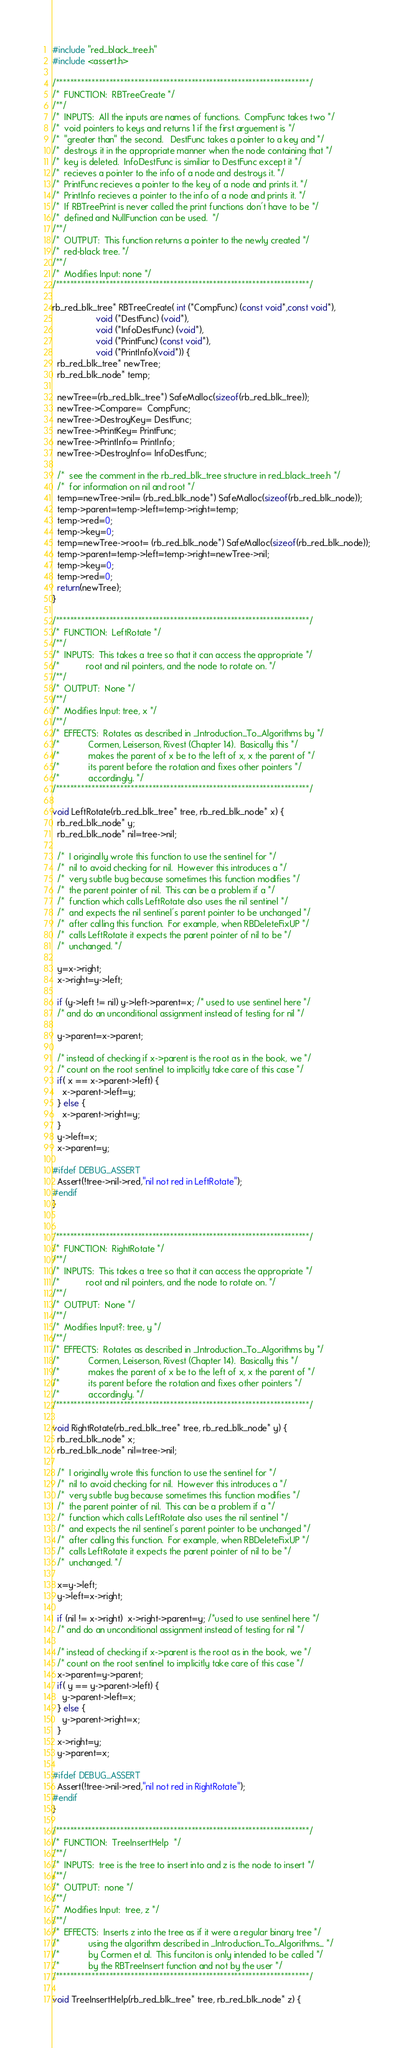<code> <loc_0><loc_0><loc_500><loc_500><_C_>#include "red_black_tree.h"
#include <assert.h>

/***********************************************************************/
/*  FUNCTION:  RBTreeCreate */
/**/
/*  INPUTS:  All the inputs are names of functions.  CompFunc takes two */
/*  void pointers to keys and returns 1 if the first arguement is */
/*  "greater than" the second.   DestFunc takes a pointer to a key and */
/*  destroys it in the appropriate manner when the node containing that */
/*  key is deleted.  InfoDestFunc is similiar to DestFunc except it */
/*  recieves a pointer to the info of a node and destroys it. */
/*  PrintFunc recieves a pointer to the key of a node and prints it. */
/*  PrintInfo recieves a pointer to the info of a node and prints it. */
/*  If RBTreePrint is never called the print functions don't have to be */
/*  defined and NullFunction can be used.  */
/**/
/*  OUTPUT:  This function returns a pointer to the newly created */
/*  red-black tree. */
/**/
/*  Modifies Input: none */
/***********************************************************************/

rb_red_blk_tree* RBTreeCreate( int (*CompFunc) (const void*,const void*),
			      void (*DestFunc) (void*),
			      void (*InfoDestFunc) (void*),
			      void (*PrintFunc) (const void*),
			      void (*PrintInfo)(void*)) {
  rb_red_blk_tree* newTree;
  rb_red_blk_node* temp;

  newTree=(rb_red_blk_tree*) SafeMalloc(sizeof(rb_red_blk_tree));
  newTree->Compare=  CompFunc;
  newTree->DestroyKey= DestFunc;
  newTree->PrintKey= PrintFunc;
  newTree->PrintInfo= PrintInfo;
  newTree->DestroyInfo= InfoDestFunc;

  /*  see the comment in the rb_red_blk_tree structure in red_black_tree.h */
  /*  for information on nil and root */
  temp=newTree->nil= (rb_red_blk_node*) SafeMalloc(sizeof(rb_red_blk_node));
  temp->parent=temp->left=temp->right=temp;
  temp->red=0;
  temp->key=0;
  temp=newTree->root= (rb_red_blk_node*) SafeMalloc(sizeof(rb_red_blk_node));
  temp->parent=temp->left=temp->right=newTree->nil;
  temp->key=0;
  temp->red=0;
  return(newTree);
}

/***********************************************************************/
/*  FUNCTION:  LeftRotate */
/**/
/*  INPUTS:  This takes a tree so that it can access the appropriate */
/*           root and nil pointers, and the node to rotate on. */
/**/
/*  OUTPUT:  None */
/**/
/*  Modifies Input: tree, x */
/**/
/*  EFFECTS:  Rotates as described in _Introduction_To_Algorithms by */
/*            Cormen, Leiserson, Rivest (Chapter 14).  Basically this */
/*            makes the parent of x be to the left of x, x the parent of */
/*            its parent before the rotation and fixes other pointers */
/*            accordingly. */
/***********************************************************************/

void LeftRotate(rb_red_blk_tree* tree, rb_red_blk_node* x) {
  rb_red_blk_node* y;
  rb_red_blk_node* nil=tree->nil;

  /*  I originally wrote this function to use the sentinel for */
  /*  nil to avoid checking for nil.  However this introduces a */
  /*  very subtle bug because sometimes this function modifies */
  /*  the parent pointer of nil.  This can be a problem if a */
  /*  function which calls LeftRotate also uses the nil sentinel */
  /*  and expects the nil sentinel's parent pointer to be unchanged */
  /*  after calling this function.  For example, when RBDeleteFixUP */
  /*  calls LeftRotate it expects the parent pointer of nil to be */
  /*  unchanged. */

  y=x->right;
  x->right=y->left;

  if (y->left != nil) y->left->parent=x; /* used to use sentinel here */
  /* and do an unconditional assignment instead of testing for nil */
  
  y->parent=x->parent;   

  /* instead of checking if x->parent is the root as in the book, we */
  /* count on the root sentinel to implicitly take care of this case */
  if( x == x->parent->left) {
    x->parent->left=y;
  } else {
    x->parent->right=y;
  }
  y->left=x;
  x->parent=y;

#ifdef DEBUG_ASSERT
  Assert(!tree->nil->red,"nil not red in LeftRotate");
#endif
}


/***********************************************************************/
/*  FUNCTION:  RightRotate */
/**/
/*  INPUTS:  This takes a tree so that it can access the appropriate */
/*           root and nil pointers, and the node to rotate on. */
/**/
/*  OUTPUT:  None */
/**/
/*  Modifies Input?: tree, y */
/**/
/*  EFFECTS:  Rotates as described in _Introduction_To_Algorithms by */
/*            Cormen, Leiserson, Rivest (Chapter 14).  Basically this */
/*            makes the parent of x be to the left of x, x the parent of */
/*            its parent before the rotation and fixes other pointers */
/*            accordingly. */
/***********************************************************************/

void RightRotate(rb_red_blk_tree* tree, rb_red_blk_node* y) {
  rb_red_blk_node* x;
  rb_red_blk_node* nil=tree->nil;

  /*  I originally wrote this function to use the sentinel for */
  /*  nil to avoid checking for nil.  However this introduces a */
  /*  very subtle bug because sometimes this function modifies */
  /*  the parent pointer of nil.  This can be a problem if a */
  /*  function which calls LeftRotate also uses the nil sentinel */
  /*  and expects the nil sentinel's parent pointer to be unchanged */
  /*  after calling this function.  For example, when RBDeleteFixUP */
  /*  calls LeftRotate it expects the parent pointer of nil to be */
  /*  unchanged. */

  x=y->left;
  y->left=x->right;

  if (nil != x->right)  x->right->parent=y; /*used to use sentinel here */
  /* and do an unconditional assignment instead of testing for nil */

  /* instead of checking if x->parent is the root as in the book, we */
  /* count on the root sentinel to implicitly take care of this case */
  x->parent=y->parent;
  if( y == y->parent->left) {
    y->parent->left=x;
  } else {
    y->parent->right=x;
  }
  x->right=y;
  y->parent=x;

#ifdef DEBUG_ASSERT
  Assert(!tree->nil->red,"nil not red in RightRotate");
#endif
}

/***********************************************************************/
/*  FUNCTION:  TreeInsertHelp  */
/**/
/*  INPUTS:  tree is the tree to insert into and z is the node to insert */
/**/
/*  OUTPUT:  none */
/**/
/*  Modifies Input:  tree, z */
/**/
/*  EFFECTS:  Inserts z into the tree as if it were a regular binary tree */
/*            using the algorithm described in _Introduction_To_Algorithms_ */
/*            by Cormen et al.  This funciton is only intended to be called */
/*            by the RBTreeInsert function and not by the user */
/***********************************************************************/

void TreeInsertHelp(rb_red_blk_tree* tree, rb_red_blk_node* z) {</code> 